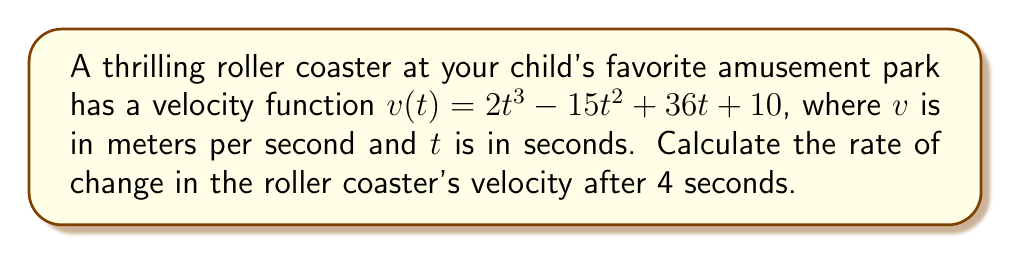What is the answer to this math problem? To find the rate of change in velocity, we need to calculate the derivative of the velocity function. This gives us the acceleration function.

1. Start with the velocity function:
   $v(t) = 2t^3 - 15t^2 + 36t + 10$

2. Calculate the derivative using the power rule:
   $\frac{dv}{dt} = 6t^2 - 30t + 36$

3. This derivative represents the acceleration function $a(t)$:
   $a(t) = 6t^2 - 30t + 36$

4. To find the rate of change in velocity after 4 seconds, substitute $t=4$ into the acceleration function:
   $a(4) = 6(4)^2 - 30(4) + 36$
   $= 6(16) - 120 + 36$
   $= 96 - 120 + 36$
   $= 12$

Therefore, the rate of change in the roller coaster's velocity after 4 seconds is 12 m/s².
Answer: 12 m/s² 